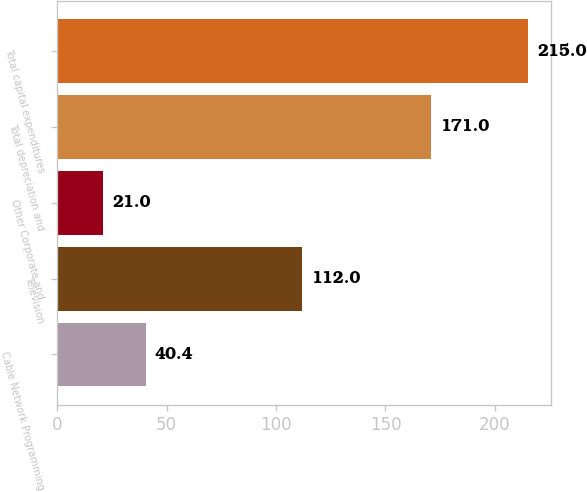<chart> <loc_0><loc_0><loc_500><loc_500><bar_chart><fcel>Cable Network Programming<fcel>Television<fcel>Other Corporate and<fcel>Total depreciation and<fcel>Total capital expenditures<nl><fcel>40.4<fcel>112<fcel>21<fcel>171<fcel>215<nl></chart> 